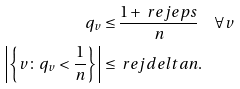Convert formula to latex. <formula><loc_0><loc_0><loc_500><loc_500>q _ { v } & \leq \frac { 1 + \ r e j e p s } { n } \quad \forall v \\ \left | \left \{ v \colon q _ { v } < \frac { 1 } { n } \right \} \right | & \leq \ r e j d e l t a n .</formula> 